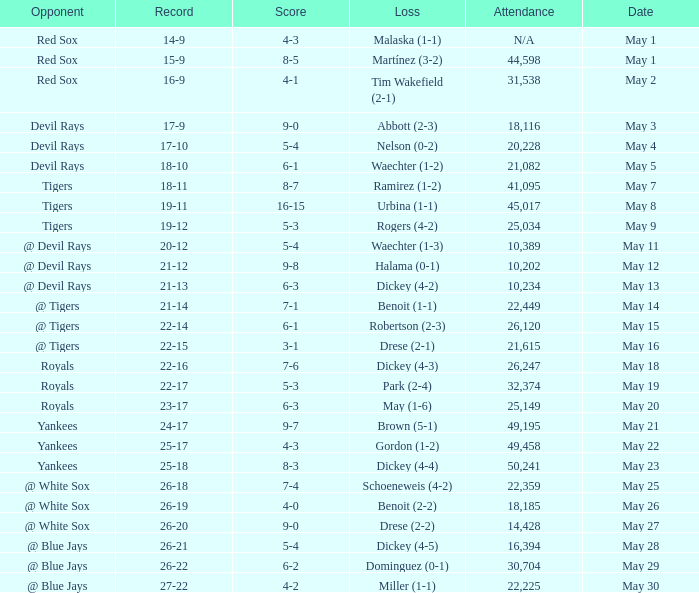What is the score of the game attended by 25,034? 5-3. 